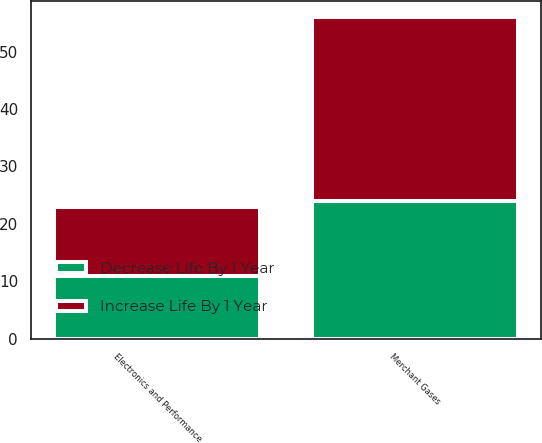Convert chart. <chart><loc_0><loc_0><loc_500><loc_500><stacked_bar_chart><ecel><fcel>Merchant Gases<fcel>Electronics and Performance<nl><fcel>Increase Life By 1 Year<fcel>32<fcel>12<nl><fcel>Decrease Life By 1 Year<fcel>24<fcel>11<nl></chart> 